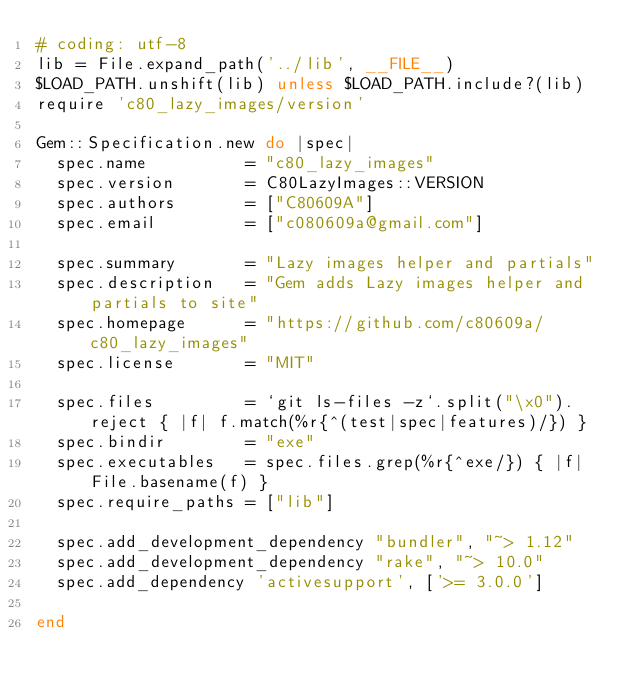Convert code to text. <code><loc_0><loc_0><loc_500><loc_500><_Ruby_># coding: utf-8
lib = File.expand_path('../lib', __FILE__)
$LOAD_PATH.unshift(lib) unless $LOAD_PATH.include?(lib)
require 'c80_lazy_images/version'

Gem::Specification.new do |spec|
  spec.name          = "c80_lazy_images"
  spec.version       = C80LazyImages::VERSION
  spec.authors       = ["C80609A"]
  spec.email         = ["c080609a@gmail.com"]

  spec.summary       = "Lazy images helper and partials"
  spec.description   = "Gem adds Lazy images helper and partials to site"
  spec.homepage      = "https://github.com/c80609a/c80_lazy_images"
  spec.license       = "MIT"

  spec.files         = `git ls-files -z`.split("\x0").reject { |f| f.match(%r{^(test|spec|features)/}) }
  spec.bindir        = "exe"
  spec.executables   = spec.files.grep(%r{^exe/}) { |f| File.basename(f) }
  spec.require_paths = ["lib"]

  spec.add_development_dependency "bundler", "~> 1.12"
  spec.add_development_dependency "rake", "~> 10.0"
  spec.add_dependency 'activesupport', ['>= 3.0.0']

end
</code> 